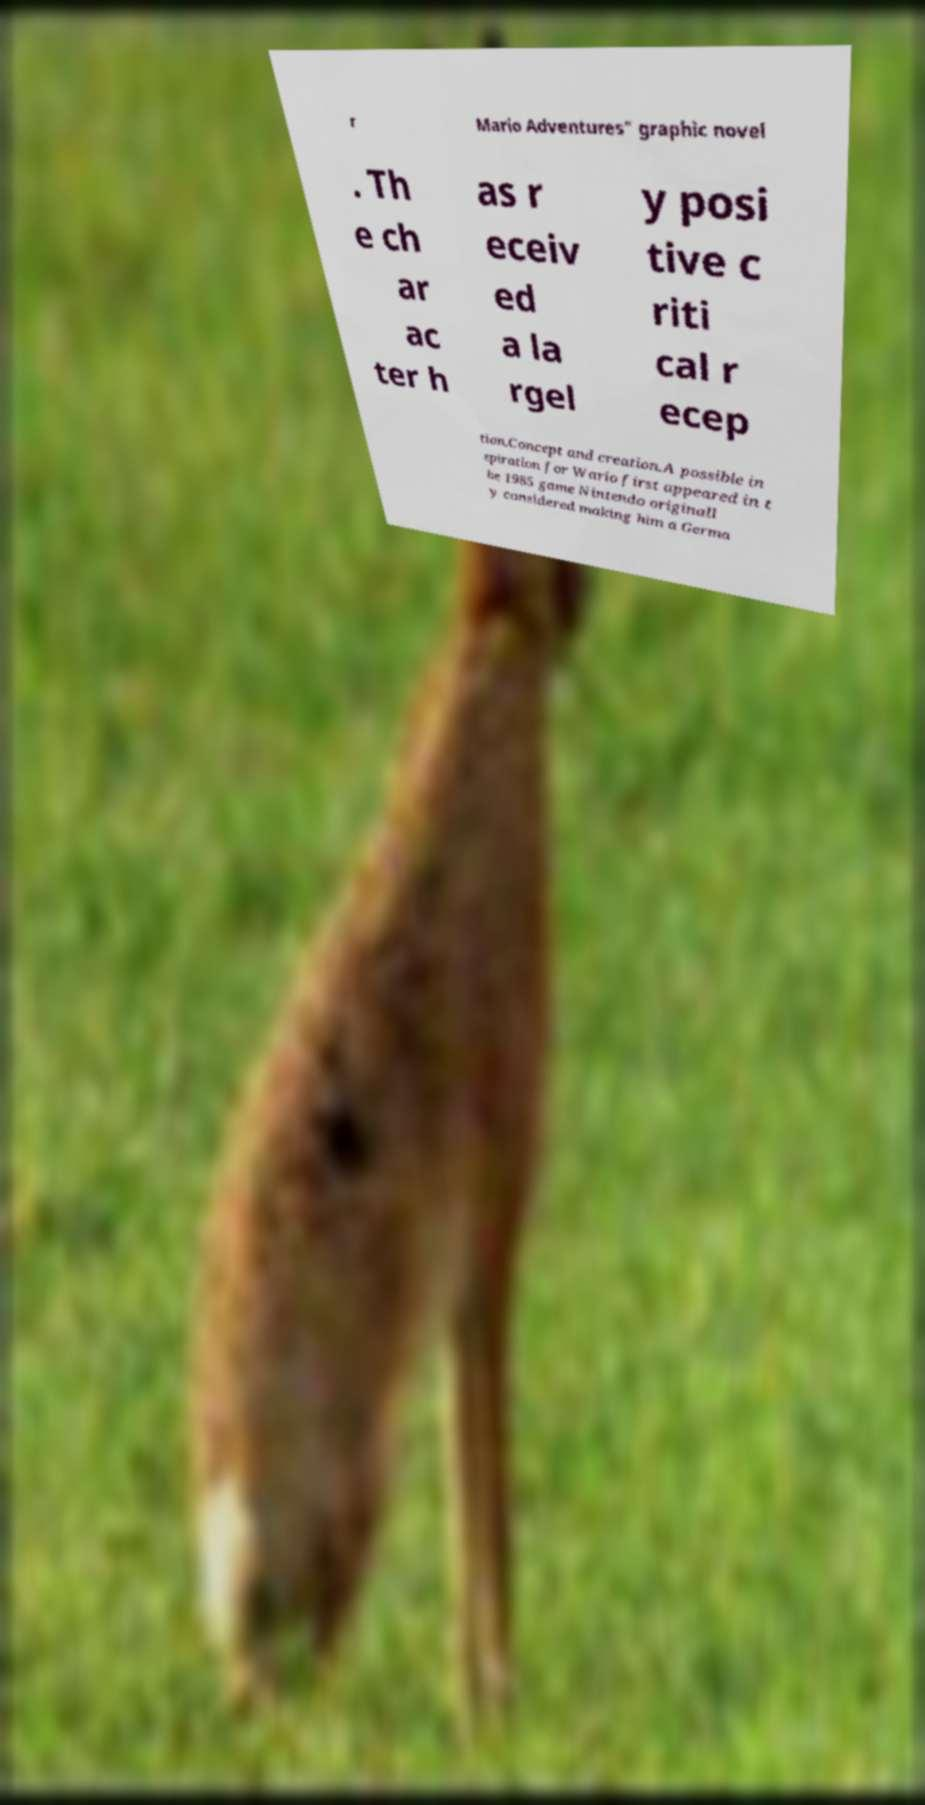Could you assist in decoding the text presented in this image and type it out clearly? r Mario Adventures" graphic novel . Th e ch ar ac ter h as r eceiv ed a la rgel y posi tive c riti cal r ecep tion.Concept and creation.A possible in spiration for Wario first appeared in t he 1985 game Nintendo originall y considered making him a Germa 